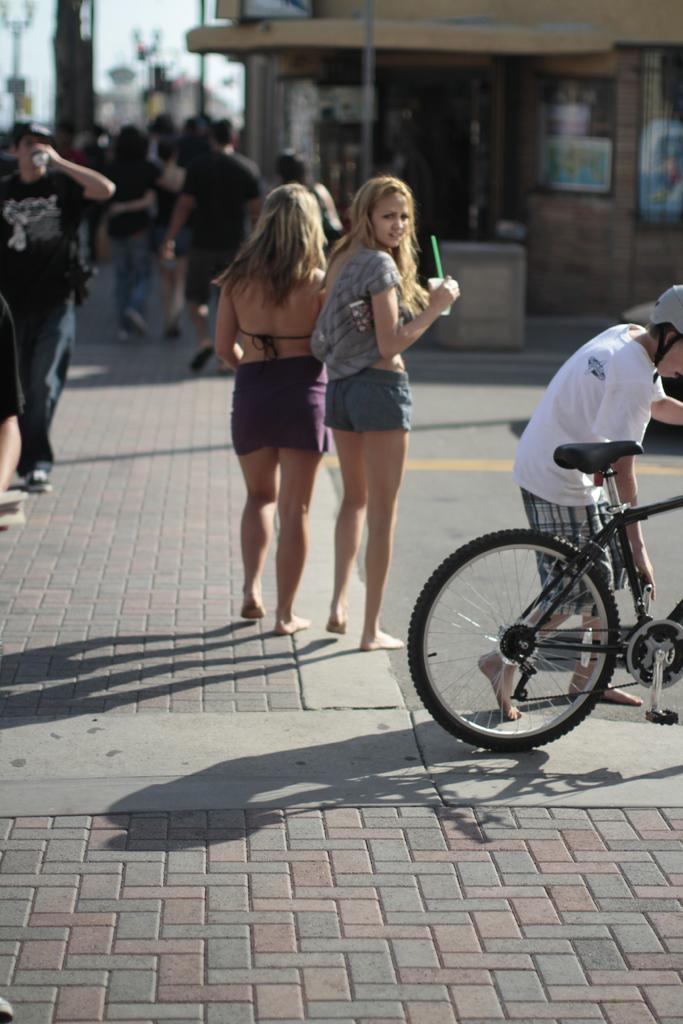How many people are in the image? There are two people in the image. What is one person doing in the image? One person is beside a bicycle. What else can be seen in the image besides the two people? There are other buildings and other people visible in the image. What type of furniture can be seen in the image? There is no furniture present in the image. What sound can be heard coming from the people in the image? The image is silent, so no sounds can be heard. 